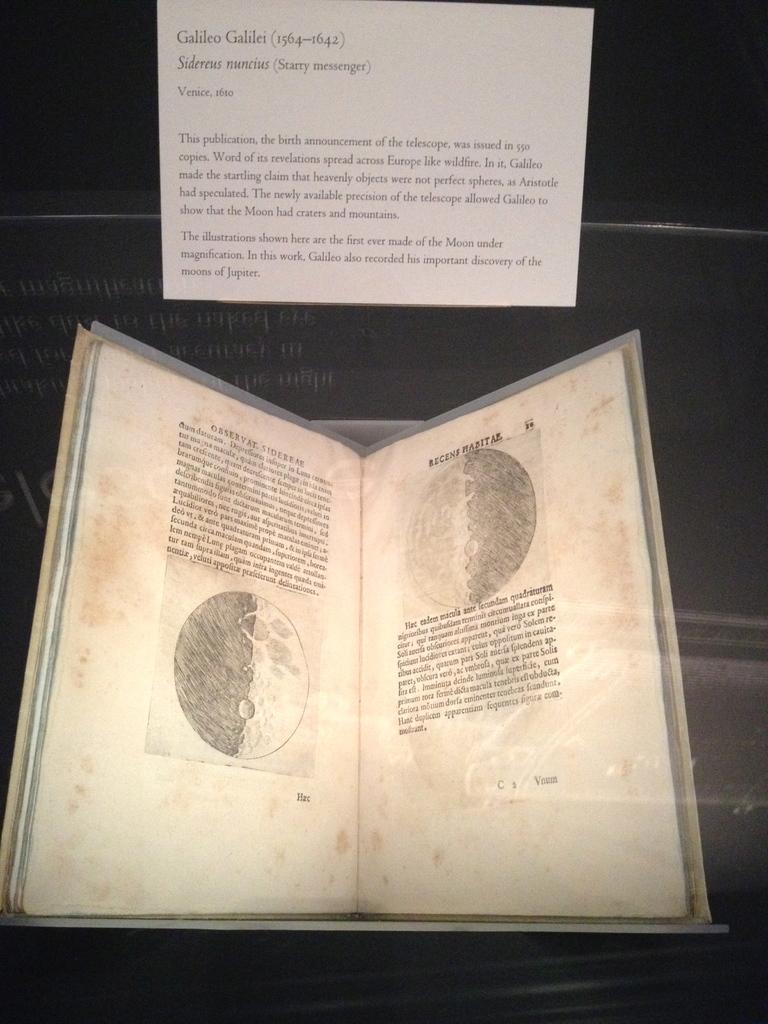What is the name of the person who wrote the book?
Offer a very short reply. Galileo galilei. What years did galileo galilei live?
Keep it short and to the point. 1564-1642. 